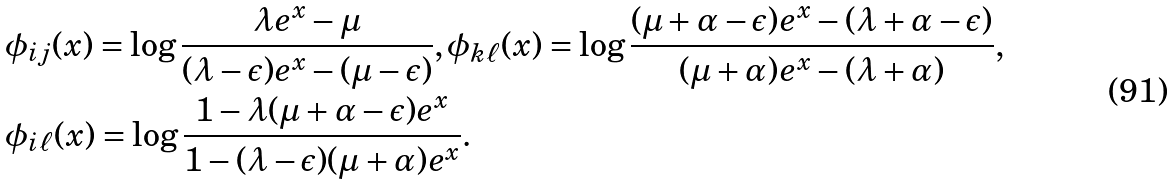Convert formula to latex. <formula><loc_0><loc_0><loc_500><loc_500>& \phi _ { i j } ( x ) = \log \frac { \lambda e ^ { x } - \mu } { ( \lambda - \epsilon ) e ^ { x } - ( \mu - \epsilon ) } , \phi _ { k \ell } ( x ) = \log \frac { ( \mu + \alpha - \epsilon ) e ^ { x } - ( \lambda + \alpha - \epsilon ) } { ( \mu + \alpha ) e ^ { x } - ( \lambda + \alpha ) } , \\ & \phi _ { i \ell } ( x ) = \log \frac { 1 - \lambda ( \mu + \alpha - \epsilon ) e ^ { x } } { 1 - ( \lambda - \epsilon ) ( \mu + \alpha ) e ^ { x } } .</formula> 